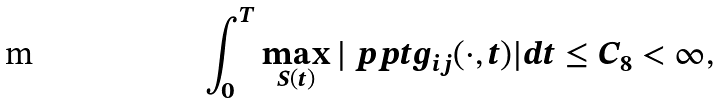<formula> <loc_0><loc_0><loc_500><loc_500>\int _ { 0 } ^ { T } \max _ { S ( t ) } | \ p p { t } g _ { i j } ( \cdot , t ) | d t \leq C _ { 8 } < \infty ,</formula> 